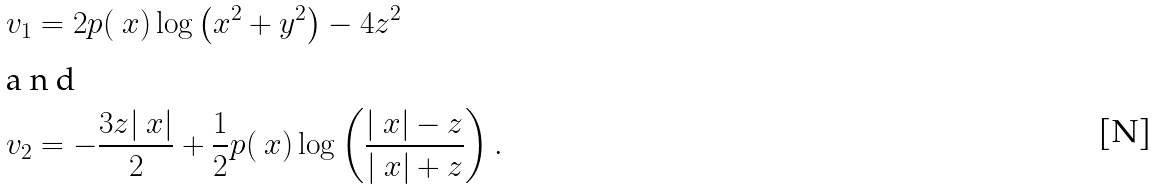<formula> <loc_0><loc_0><loc_500><loc_500>& v _ { 1 } = 2 p ( \ x ) \log \left ( x ^ { 2 } + y ^ { 2 } \right ) - 4 z ^ { 2 } \intertext { a n d } & v _ { 2 } = - \frac { 3 z | \ x | } { 2 } + \frac { 1 } { 2 } p ( \ x ) \log \left ( \frac { | \ x | - z } { | \ x | + z } \right ) .</formula> 